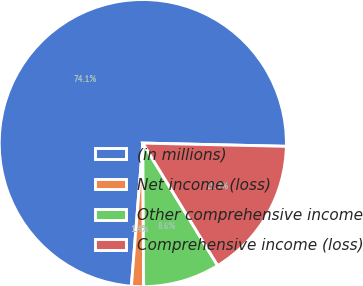Convert chart to OTSL. <chart><loc_0><loc_0><loc_500><loc_500><pie_chart><fcel>(in millions)<fcel>Net income (loss)<fcel>Other comprehensive income<fcel>Comprehensive income (loss)<nl><fcel>74.09%<fcel>1.36%<fcel>8.64%<fcel>15.91%<nl></chart> 